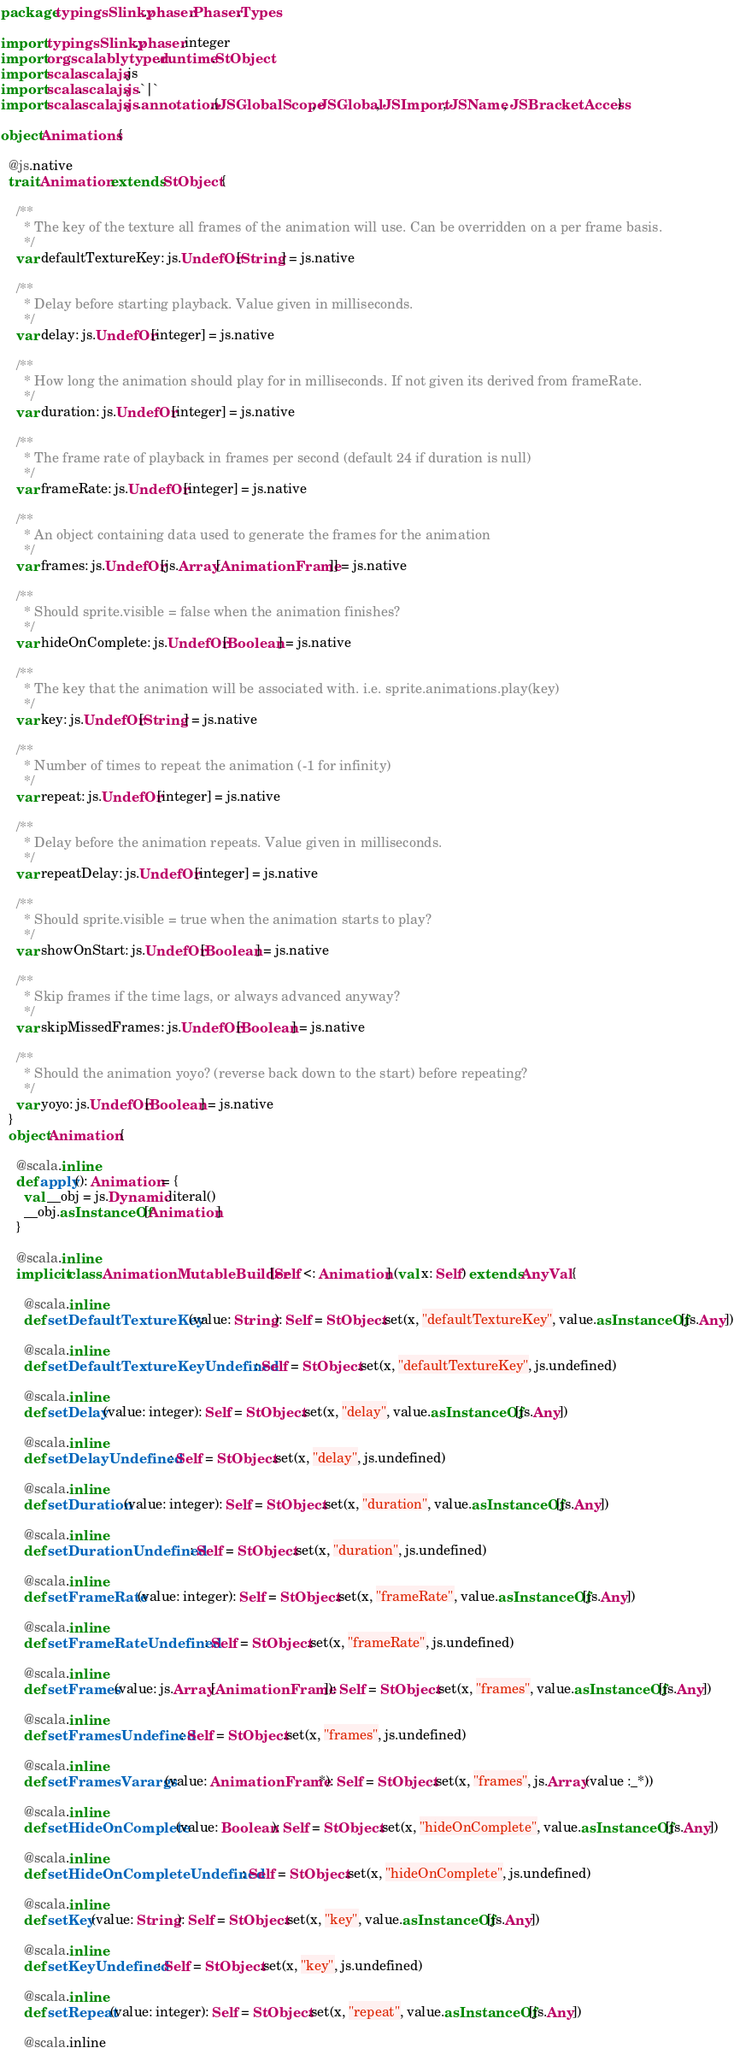Convert code to text. <code><loc_0><loc_0><loc_500><loc_500><_Scala_>package typingsSlinky.phaser.Phaser.Types

import typingsSlinky.phaser.integer
import org.scalablytyped.runtime.StObject
import scala.scalajs.js
import scala.scalajs.js.`|`
import scala.scalajs.js.annotation.{JSGlobalScope, JSGlobal, JSImport, JSName, JSBracketAccess}

object Animations {
  
  @js.native
  trait Animation extends StObject {
    
    /**
      * The key of the texture all frames of the animation will use. Can be overridden on a per frame basis.
      */
    var defaultTextureKey: js.UndefOr[String] = js.native
    
    /**
      * Delay before starting playback. Value given in milliseconds.
      */
    var delay: js.UndefOr[integer] = js.native
    
    /**
      * How long the animation should play for in milliseconds. If not given its derived from frameRate.
      */
    var duration: js.UndefOr[integer] = js.native
    
    /**
      * The frame rate of playback in frames per second (default 24 if duration is null)
      */
    var frameRate: js.UndefOr[integer] = js.native
    
    /**
      * An object containing data used to generate the frames for the animation
      */
    var frames: js.UndefOr[js.Array[AnimationFrame]] = js.native
    
    /**
      * Should sprite.visible = false when the animation finishes?
      */
    var hideOnComplete: js.UndefOr[Boolean] = js.native
    
    /**
      * The key that the animation will be associated with. i.e. sprite.animations.play(key)
      */
    var key: js.UndefOr[String] = js.native
    
    /**
      * Number of times to repeat the animation (-1 for infinity)
      */
    var repeat: js.UndefOr[integer] = js.native
    
    /**
      * Delay before the animation repeats. Value given in milliseconds.
      */
    var repeatDelay: js.UndefOr[integer] = js.native
    
    /**
      * Should sprite.visible = true when the animation starts to play?
      */
    var showOnStart: js.UndefOr[Boolean] = js.native
    
    /**
      * Skip frames if the time lags, or always advanced anyway?
      */
    var skipMissedFrames: js.UndefOr[Boolean] = js.native
    
    /**
      * Should the animation yoyo? (reverse back down to the start) before repeating?
      */
    var yoyo: js.UndefOr[Boolean] = js.native
  }
  object Animation {
    
    @scala.inline
    def apply(): Animation = {
      val __obj = js.Dynamic.literal()
      __obj.asInstanceOf[Animation]
    }
    
    @scala.inline
    implicit class AnimationMutableBuilder[Self <: Animation] (val x: Self) extends AnyVal {
      
      @scala.inline
      def setDefaultTextureKey(value: String): Self = StObject.set(x, "defaultTextureKey", value.asInstanceOf[js.Any])
      
      @scala.inline
      def setDefaultTextureKeyUndefined: Self = StObject.set(x, "defaultTextureKey", js.undefined)
      
      @scala.inline
      def setDelay(value: integer): Self = StObject.set(x, "delay", value.asInstanceOf[js.Any])
      
      @scala.inline
      def setDelayUndefined: Self = StObject.set(x, "delay", js.undefined)
      
      @scala.inline
      def setDuration(value: integer): Self = StObject.set(x, "duration", value.asInstanceOf[js.Any])
      
      @scala.inline
      def setDurationUndefined: Self = StObject.set(x, "duration", js.undefined)
      
      @scala.inline
      def setFrameRate(value: integer): Self = StObject.set(x, "frameRate", value.asInstanceOf[js.Any])
      
      @scala.inline
      def setFrameRateUndefined: Self = StObject.set(x, "frameRate", js.undefined)
      
      @scala.inline
      def setFrames(value: js.Array[AnimationFrame]): Self = StObject.set(x, "frames", value.asInstanceOf[js.Any])
      
      @scala.inline
      def setFramesUndefined: Self = StObject.set(x, "frames", js.undefined)
      
      @scala.inline
      def setFramesVarargs(value: AnimationFrame*): Self = StObject.set(x, "frames", js.Array(value :_*))
      
      @scala.inline
      def setHideOnComplete(value: Boolean): Self = StObject.set(x, "hideOnComplete", value.asInstanceOf[js.Any])
      
      @scala.inline
      def setHideOnCompleteUndefined: Self = StObject.set(x, "hideOnComplete", js.undefined)
      
      @scala.inline
      def setKey(value: String): Self = StObject.set(x, "key", value.asInstanceOf[js.Any])
      
      @scala.inline
      def setKeyUndefined: Self = StObject.set(x, "key", js.undefined)
      
      @scala.inline
      def setRepeat(value: integer): Self = StObject.set(x, "repeat", value.asInstanceOf[js.Any])
      
      @scala.inline</code> 